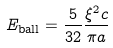Convert formula to latex. <formula><loc_0><loc_0><loc_500><loc_500>E _ { \text {ball} } = \frac { 5 } { 3 2 } \frac { \xi ^ { 2 } c } { \pi a }</formula> 